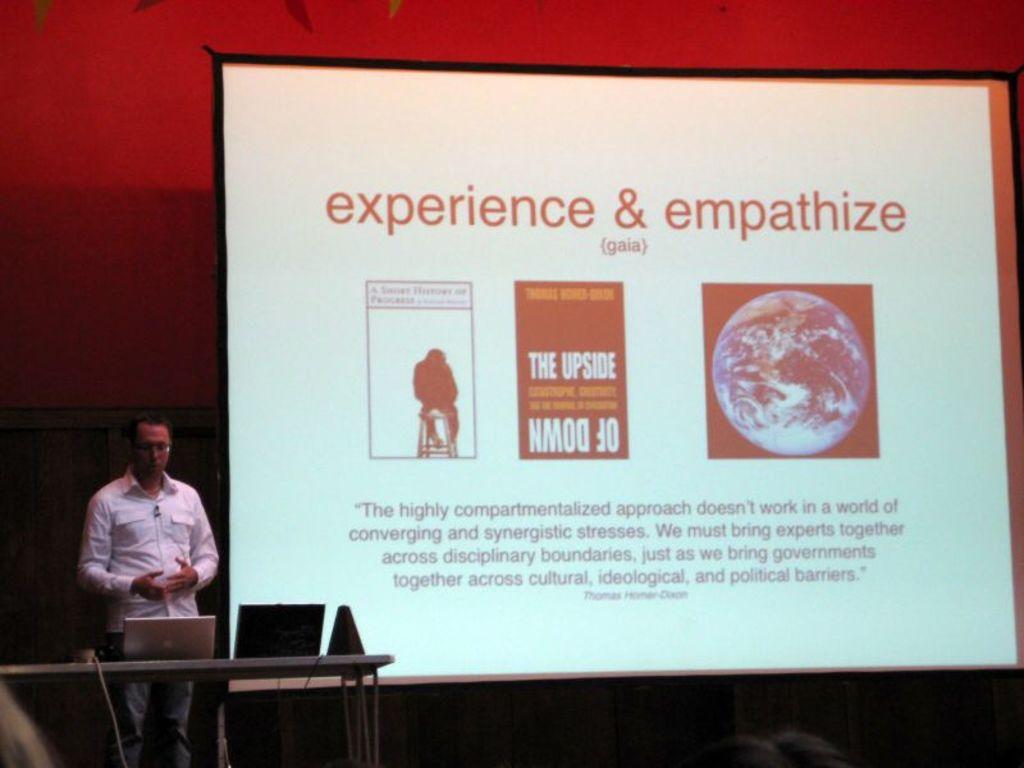What is this presentation about?
Ensure brevity in your answer.  Experience & empathize. What type of approach does the slide talk about?
Provide a succinct answer. Highly compartmentalized. 